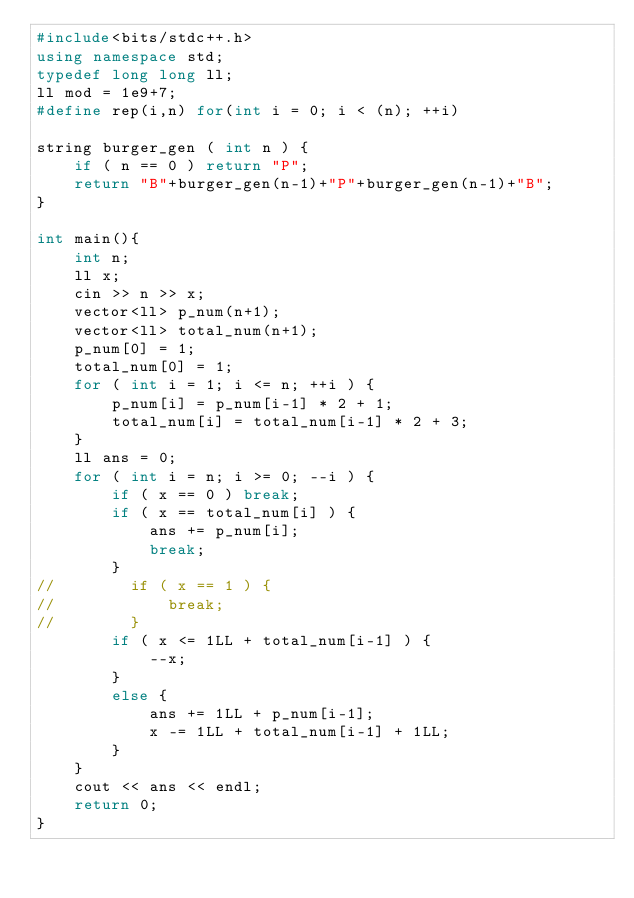<code> <loc_0><loc_0><loc_500><loc_500><_C++_>#include<bits/stdc++.h>
using namespace std;
typedef long long ll;
ll mod = 1e9+7;
#define rep(i,n) for(int i = 0; i < (n); ++i)

string burger_gen ( int n ) {
    if ( n == 0 ) return "P";
    return "B"+burger_gen(n-1)+"P"+burger_gen(n-1)+"B";
}

int main(){
    int n;
    ll x;
    cin >> n >> x;
    vector<ll> p_num(n+1);
    vector<ll> total_num(n+1);
    p_num[0] = 1;
    total_num[0] = 1;
    for ( int i = 1; i <= n; ++i ) {
        p_num[i] = p_num[i-1] * 2 + 1;
        total_num[i] = total_num[i-1] * 2 + 3;
    }
    ll ans = 0;
    for ( int i = n; i >= 0; --i ) {
        if ( x == 0 ) break;
        if ( x == total_num[i] ) {
            ans += p_num[i];
            break;
        }
//        if ( x == 1 ) {
//            break;
//        }
        if ( x <= 1LL + total_num[i-1] ) {
            --x;
        }
        else {
            ans += 1LL + p_num[i-1];
            x -= 1LL + total_num[i-1] + 1LL;
        }
    }
    cout << ans << endl;
    return 0;
}
</code> 